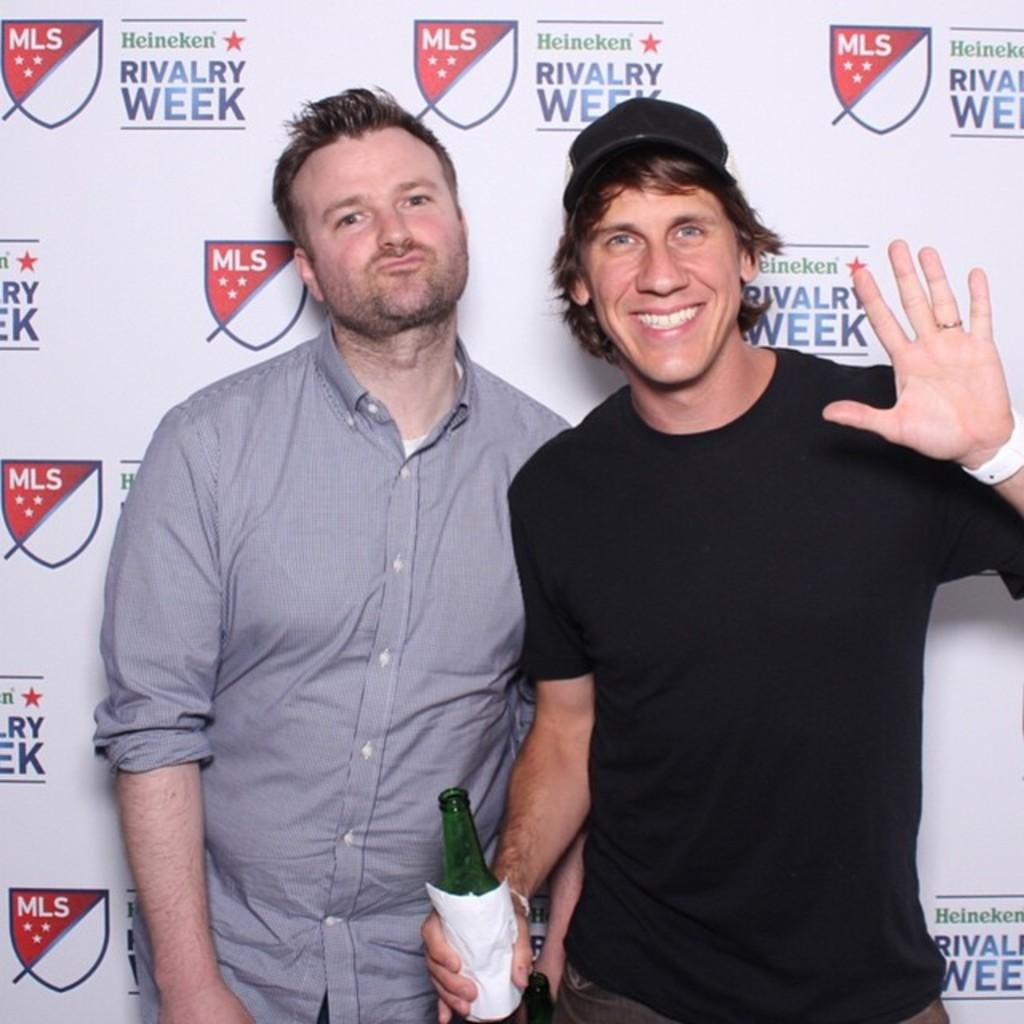How many people are in the image? There are two men in the image. What is the facial expression of one of the men? One of the men is smiling. What is the man holding in his right hand? The man is holding a beer bottle in his right hand. What can be seen in the background of the image? There is a banner visible in the image. What type of horse can be seen in the image? There is no horse present in the image. How does the pump function in the image? There is no pump present in the image. 